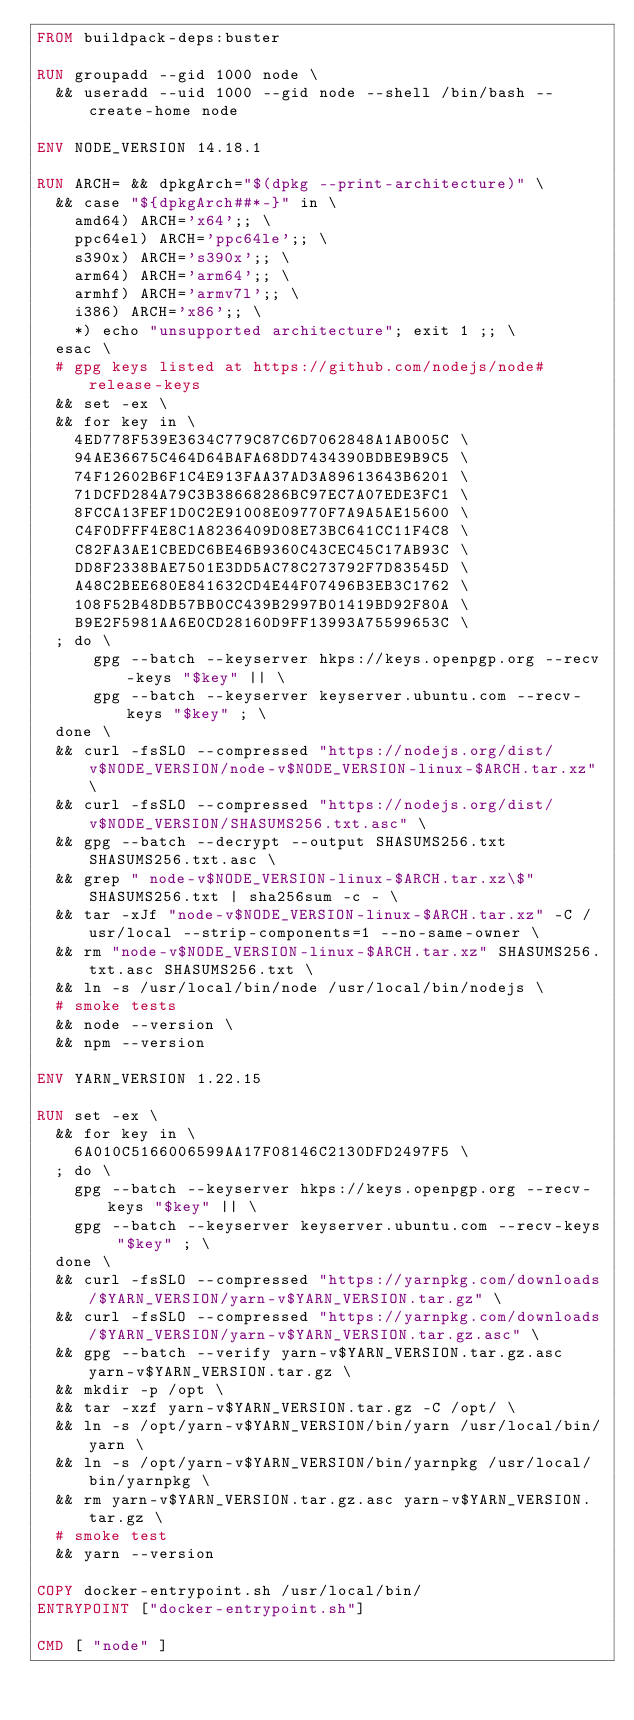<code> <loc_0><loc_0><loc_500><loc_500><_Dockerfile_>FROM buildpack-deps:buster

RUN groupadd --gid 1000 node \
  && useradd --uid 1000 --gid node --shell /bin/bash --create-home node

ENV NODE_VERSION 14.18.1

RUN ARCH= && dpkgArch="$(dpkg --print-architecture)" \
  && case "${dpkgArch##*-}" in \
    amd64) ARCH='x64';; \
    ppc64el) ARCH='ppc64le';; \
    s390x) ARCH='s390x';; \
    arm64) ARCH='arm64';; \
    armhf) ARCH='armv7l';; \
    i386) ARCH='x86';; \
    *) echo "unsupported architecture"; exit 1 ;; \
  esac \
  # gpg keys listed at https://github.com/nodejs/node#release-keys
  && set -ex \
  && for key in \
    4ED778F539E3634C779C87C6D7062848A1AB005C \
    94AE36675C464D64BAFA68DD7434390BDBE9B9C5 \
    74F12602B6F1C4E913FAA37AD3A89613643B6201 \
    71DCFD284A79C3B38668286BC97EC7A07EDE3FC1 \
    8FCCA13FEF1D0C2E91008E09770F7A9A5AE15600 \
    C4F0DFFF4E8C1A8236409D08E73BC641CC11F4C8 \
    C82FA3AE1CBEDC6BE46B9360C43CEC45C17AB93C \
    DD8F2338BAE7501E3DD5AC78C273792F7D83545D \
    A48C2BEE680E841632CD4E44F07496B3EB3C1762 \
    108F52B48DB57BB0CC439B2997B01419BD92F80A \
    B9E2F5981AA6E0CD28160D9FF13993A75599653C \
  ; do \
      gpg --batch --keyserver hkps://keys.openpgp.org --recv-keys "$key" || \
      gpg --batch --keyserver keyserver.ubuntu.com --recv-keys "$key" ; \
  done \
  && curl -fsSLO --compressed "https://nodejs.org/dist/v$NODE_VERSION/node-v$NODE_VERSION-linux-$ARCH.tar.xz" \
  && curl -fsSLO --compressed "https://nodejs.org/dist/v$NODE_VERSION/SHASUMS256.txt.asc" \
  && gpg --batch --decrypt --output SHASUMS256.txt SHASUMS256.txt.asc \
  && grep " node-v$NODE_VERSION-linux-$ARCH.tar.xz\$" SHASUMS256.txt | sha256sum -c - \
  && tar -xJf "node-v$NODE_VERSION-linux-$ARCH.tar.xz" -C /usr/local --strip-components=1 --no-same-owner \
  && rm "node-v$NODE_VERSION-linux-$ARCH.tar.xz" SHASUMS256.txt.asc SHASUMS256.txt \
  && ln -s /usr/local/bin/node /usr/local/bin/nodejs \
  # smoke tests
  && node --version \
  && npm --version

ENV YARN_VERSION 1.22.15

RUN set -ex \
  && for key in \
    6A010C5166006599AA17F08146C2130DFD2497F5 \
  ; do \
    gpg --batch --keyserver hkps://keys.openpgp.org --recv-keys "$key" || \
    gpg --batch --keyserver keyserver.ubuntu.com --recv-keys "$key" ; \
  done \
  && curl -fsSLO --compressed "https://yarnpkg.com/downloads/$YARN_VERSION/yarn-v$YARN_VERSION.tar.gz" \
  && curl -fsSLO --compressed "https://yarnpkg.com/downloads/$YARN_VERSION/yarn-v$YARN_VERSION.tar.gz.asc" \
  && gpg --batch --verify yarn-v$YARN_VERSION.tar.gz.asc yarn-v$YARN_VERSION.tar.gz \
  && mkdir -p /opt \
  && tar -xzf yarn-v$YARN_VERSION.tar.gz -C /opt/ \
  && ln -s /opt/yarn-v$YARN_VERSION/bin/yarn /usr/local/bin/yarn \
  && ln -s /opt/yarn-v$YARN_VERSION/bin/yarnpkg /usr/local/bin/yarnpkg \
  && rm yarn-v$YARN_VERSION.tar.gz.asc yarn-v$YARN_VERSION.tar.gz \
  # smoke test
  && yarn --version

COPY docker-entrypoint.sh /usr/local/bin/
ENTRYPOINT ["docker-entrypoint.sh"]

CMD [ "node" ]
</code> 